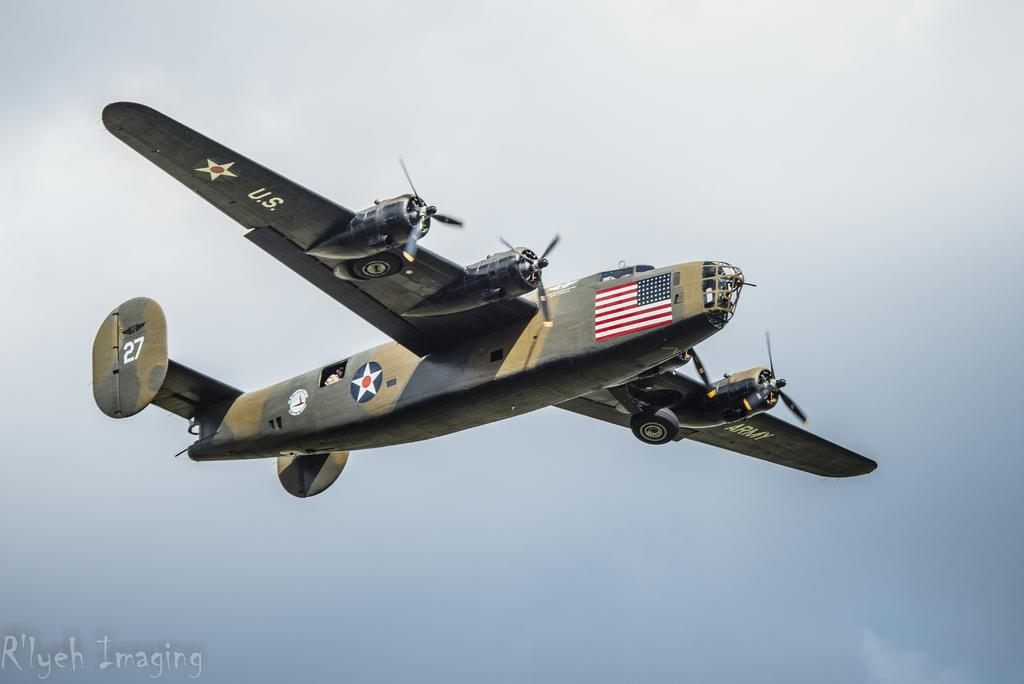What is the main subject of the picture? The main subject of the picture is an aircraft. What can be seen in the background of the picture? The sky is visible in the background of the picture. What type of toys can be seen in the picture? There are no toys present in the picture; it features an aircraft and the sky. What game is being played by the son in the picture? There is no son or game present in the picture. 